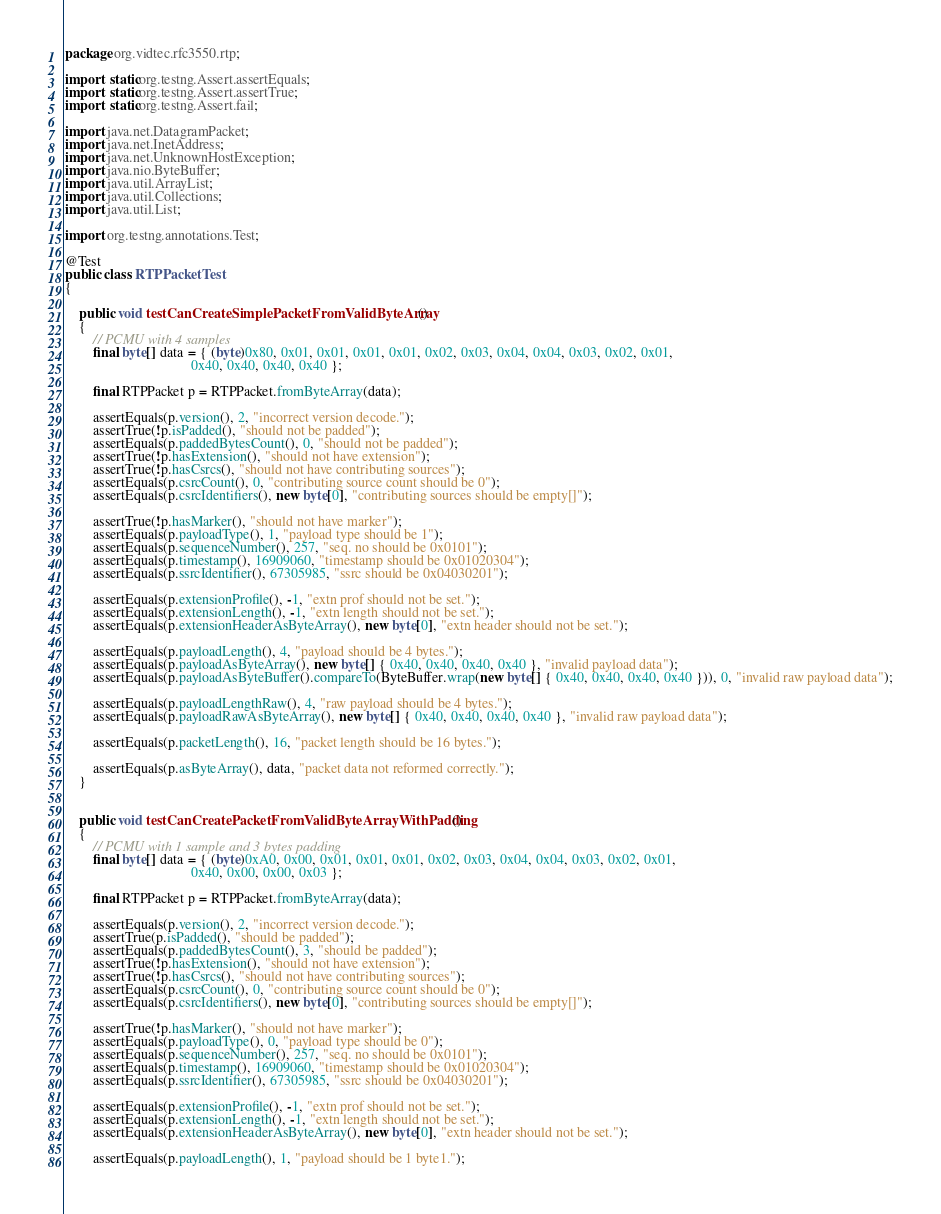Convert code to text. <code><loc_0><loc_0><loc_500><loc_500><_Java_>package org.vidtec.rfc3550.rtp;

import static org.testng.Assert.assertEquals;
import static org.testng.Assert.assertTrue;
import static org.testng.Assert.fail;

import java.net.DatagramPacket;
import java.net.InetAddress;
import java.net.UnknownHostException;
import java.nio.ByteBuffer;
import java.util.ArrayList;
import java.util.Collections;
import java.util.List;

import org.testng.annotations.Test;

@Test
public class RTPPacketTest 
{

	public void testCanCreateSimplePacketFromValidByteArray()
	{
		// PCMU with 4 samples
		final byte[] data = { (byte)0x80, 0x01, 0x01, 0x01, 0x01, 0x02, 0x03, 0x04, 0x04, 0x03, 0x02, 0x01, 
								    0x40, 0x40, 0x40, 0x40 };
		
		final RTPPacket p = RTPPacket.fromByteArray(data);
		
		assertEquals(p.version(), 2, "incorrect version decode.");
		assertTrue(!p.isPadded(), "should not be padded");
		assertEquals(p.paddedBytesCount(), 0, "should not be padded");
		assertTrue(!p.hasExtension(), "should not have extension");
		assertTrue(!p.hasCsrcs(), "should not have contributing sources");
		assertEquals(p.csrcCount(), 0, "contributing source count should be 0");
		assertEquals(p.csrcIdentifiers(), new byte[0], "contributing sources should be empty[]");
	
		assertTrue(!p.hasMarker(), "should not have marker");
		assertEquals(p.payloadType(), 1, "payload type should be 1");
		assertEquals(p.sequenceNumber(), 257, "seq. no should be 0x0101");
		assertEquals(p.timestamp(), 16909060, "timestamp should be 0x01020304");
		assertEquals(p.ssrcIdentifier(), 67305985, "ssrc should be 0x04030201");
	
		assertEquals(p.extensionProfile(), -1, "extn prof should not be set.");
		assertEquals(p.extensionLength(), -1, "extn length should not be set.");
		assertEquals(p.extensionHeaderAsByteArray(), new byte[0], "extn header should not be set.");
		
		assertEquals(p.payloadLength(), 4, "payload should be 4 bytes.");
		assertEquals(p.payloadAsByteArray(), new byte[] { 0x40, 0x40, 0x40, 0x40 }, "invalid payload data");
		assertEquals(p.payloadAsByteBuffer().compareTo(ByteBuffer.wrap(new byte[] { 0x40, 0x40, 0x40, 0x40 })), 0, "invalid raw payload data");

		assertEquals(p.payloadLengthRaw(), 4, "raw payload should be 4 bytes.");
		assertEquals(p.payloadRawAsByteArray(), new byte[] { 0x40, 0x40, 0x40, 0x40 }, "invalid raw payload data");

		assertEquals(p.packetLength(), 16, "packet length should be 16 bytes.");
		
		assertEquals(p.asByteArray(), data, "packet data not reformed correctly.");
	}
	

	public void testCanCreatePacketFromValidByteArrayWithPadding()
	{
		// PCMU with 1 sample and 3 bytes padding
		final byte[] data = { (byte)0xA0, 0x00, 0x01, 0x01, 0x01, 0x02, 0x03, 0x04, 0x04, 0x03, 0x02, 0x01, 
								    0x40, 0x00, 0x00, 0x03 };
		
		final RTPPacket p = RTPPacket.fromByteArray(data);
		
		assertEquals(p.version(), 2, "incorrect version decode.");
		assertTrue(p.isPadded(), "should be padded");
		assertEquals(p.paddedBytesCount(), 3, "should be padded");
		assertTrue(!p.hasExtension(), "should not have extension");
		assertTrue(!p.hasCsrcs(), "should not have contributing sources");
		assertEquals(p.csrcCount(), 0, "contributing source count should be 0");
		assertEquals(p.csrcIdentifiers(), new byte[0], "contributing sources should be empty[]");
	
		assertTrue(!p.hasMarker(), "should not have marker");
		assertEquals(p.payloadType(), 0, "payload type should be 0");
		assertEquals(p.sequenceNumber(), 257, "seq. no should be 0x0101");
		assertEquals(p.timestamp(), 16909060, "timestamp should be 0x01020304");
		assertEquals(p.ssrcIdentifier(), 67305985, "ssrc should be 0x04030201");
	
		assertEquals(p.extensionProfile(), -1, "extn prof should not be set.");
		assertEquals(p.extensionLength(), -1, "extn length should not be set.");
		assertEquals(p.extensionHeaderAsByteArray(), new byte[0], "extn header should not be set.");
	
		assertEquals(p.payloadLength(), 1, "payload should be 1 byte1.");</code> 